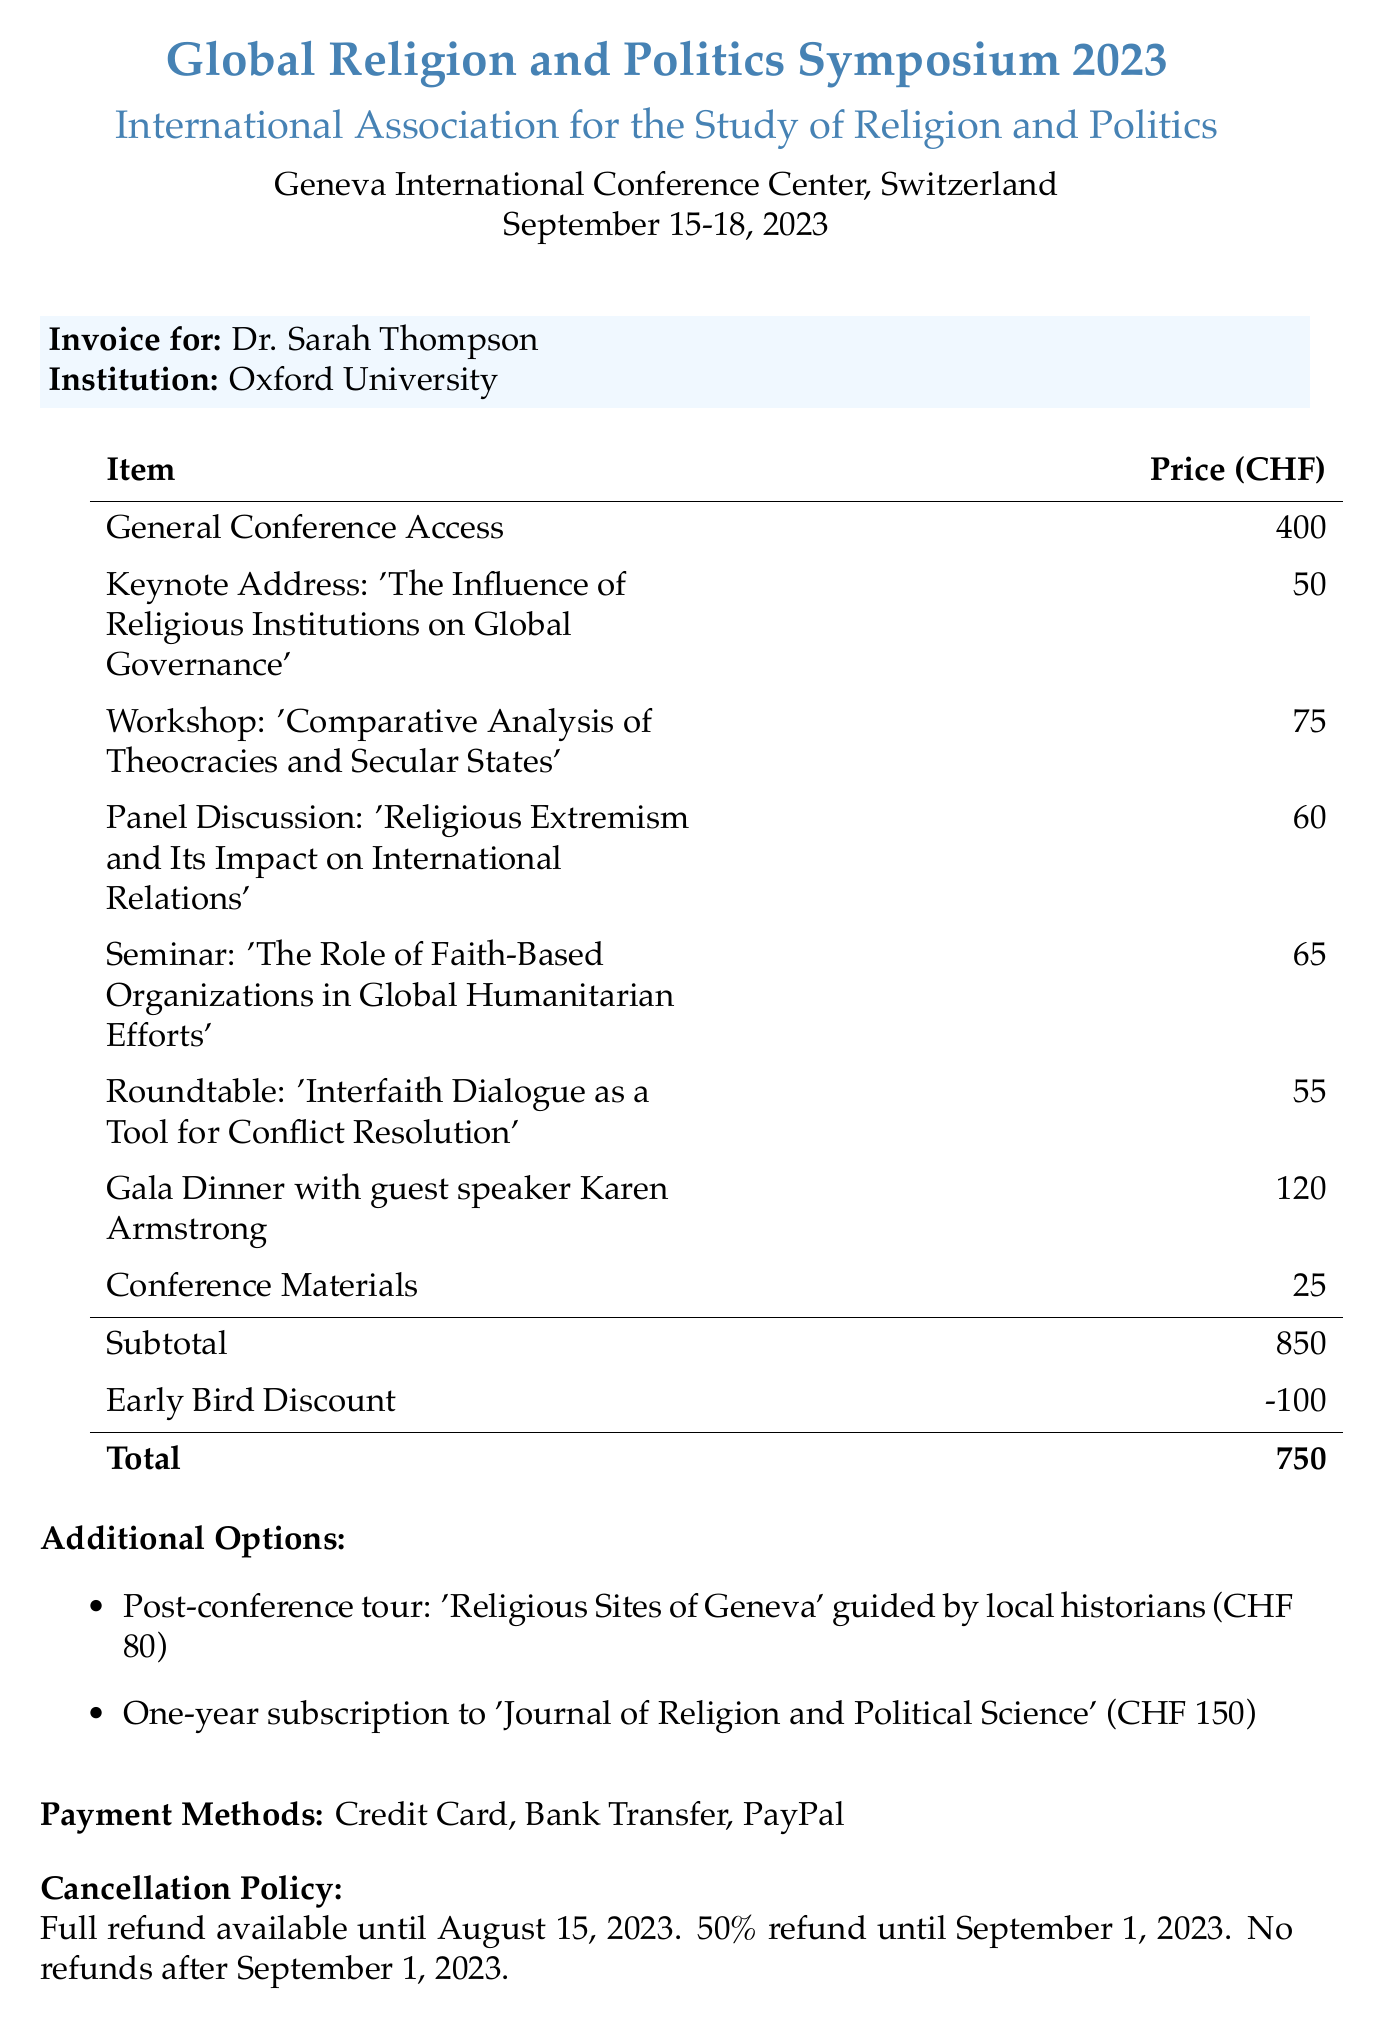What is the name of the conference? The document states that the name of the conference is the "Global Religion and Politics Symposium 2023."
Answer: Global Religion and Politics Symposium 2023 Who hosted the conference? The host organization listed in the document is the "International Association for the Study of Religion and Politics."
Answer: International Association for the Study of Religion and Politics What is the total registration fee after the early bird discount? The total fee is calculated as the subtotal minus the early bird discount, which is 850 - 100 = 750.
Answer: 750 What is the price of the gala dinner? The document specifies that the price for the gala dinner is 120 CHF.
Answer: 120 What is the cancellation policy for refunds? The cancellation policy indicates specifics about refunds, stating that there is no refund after September 1, 2023.
Answer: No refunds after September 1, 2023 What is the date range of the conference? The document mentions the dates for the conference as September 15-18, 2023.
Answer: September 15-18, 2023 What type of seminar is included in the itemized costs? The seminar listed is titled "The Role of Faith-Based Organizations in Global Humanitarian Efforts."
Answer: The Role of Faith-Based Organizations in Global Humanitarian Efforts How can attendees pay for the registration fee? The document provides multiple payment options, specifically mentioning credit card, bank transfer, and PayPal.
Answer: Credit Card, Bank Transfer, PayPal 